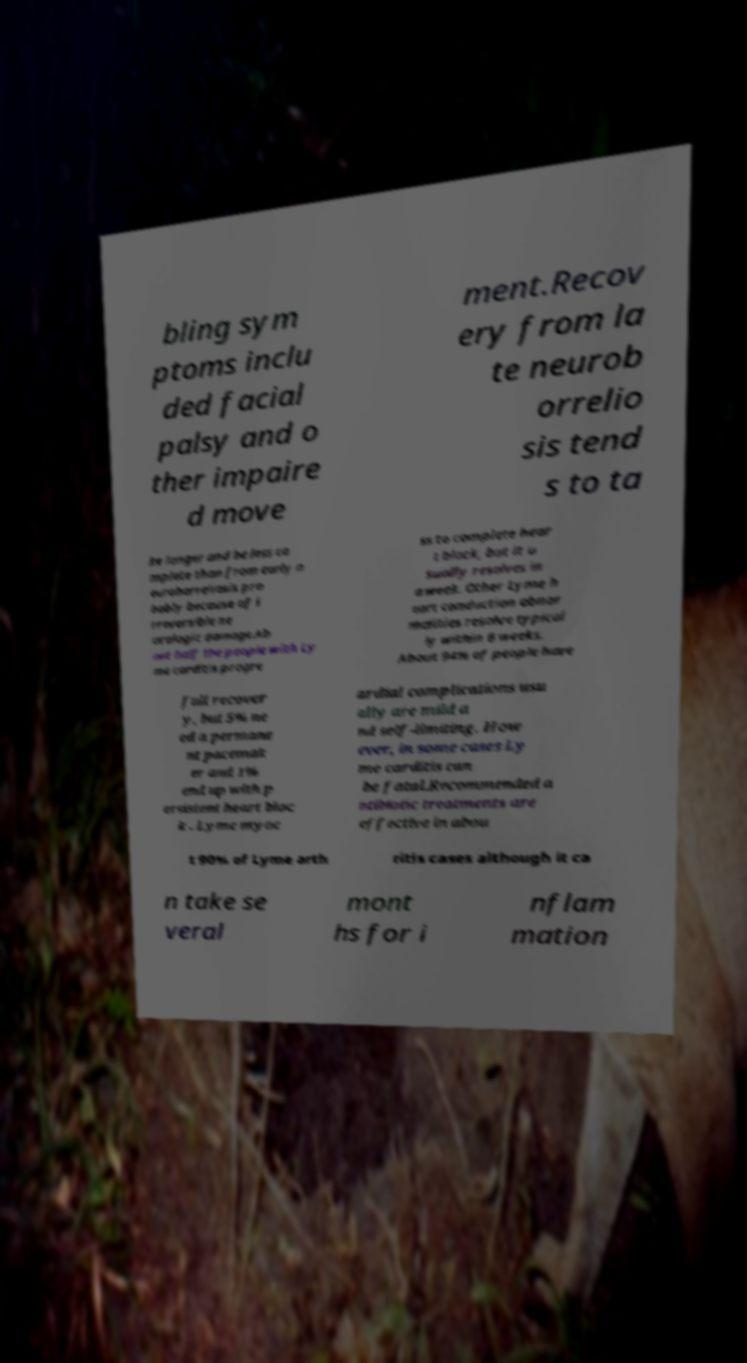Please identify and transcribe the text found in this image. bling sym ptoms inclu ded facial palsy and o ther impaire d move ment.Recov ery from la te neurob orrelio sis tend s to ta ke longer and be less co mplete than from early n euroborreliosis pro bably because of i rreversible ne urologic damage.Ab out half the people with Ly me carditis progre ss to complete hear t block, but it u sually resolves in a week. Other Lyme h eart conduction abnor malities resolve typical ly within 6 weeks. About 94% of people have full recover y, but 5% ne ed a permane nt pacemak er and 1% end up with p ersistent heart bloc k . Lyme myoc ardial complications usu ally are mild a nd self-limiting. How ever, in some cases Ly me carditis can be fatal.Recommended a ntibiotic treatments are effective in abou t 90% of Lyme arth ritis cases although it ca n take se veral mont hs for i nflam mation 